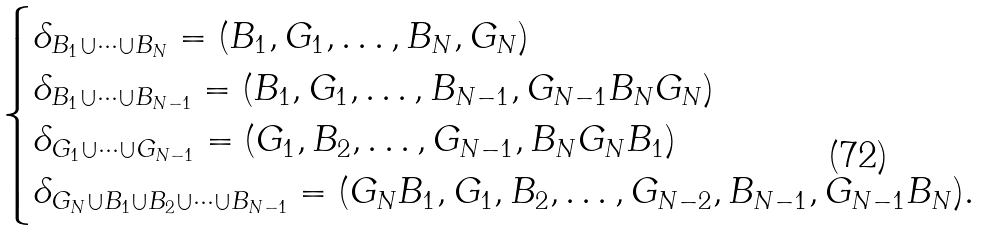Convert formula to latex. <formula><loc_0><loc_0><loc_500><loc_500>\begin{cases} \delta _ { B _ { 1 } \cup \cdots \cup B _ { N } } = ( B _ { 1 } , G _ { 1 } , \dots , B _ { N } , G _ { N } ) \\ \delta _ { B _ { 1 } \cup \cdots \cup B _ { N - 1 } } = ( B _ { 1 } , G _ { 1 } , \dots , B _ { N - 1 } , G _ { N - 1 } B _ { N } G _ { N } ) \\ \delta _ { G _ { 1 } \cup \cdots \cup G _ { N - 1 } } = ( G _ { 1 } , B _ { 2 } , \dots , G _ { N - 1 } , B _ { N } G _ { N } B _ { 1 } ) \\ \delta _ { G _ { N } \cup B _ { 1 } \cup B _ { 2 } \cup \cdots \cup B _ { N - 1 } } = ( G _ { N } B _ { 1 } , G _ { 1 } , B _ { 2 } , \dots , G _ { N - 2 } , B _ { N - 1 } , G _ { N - 1 } B _ { N } ) . \end{cases}</formula> 